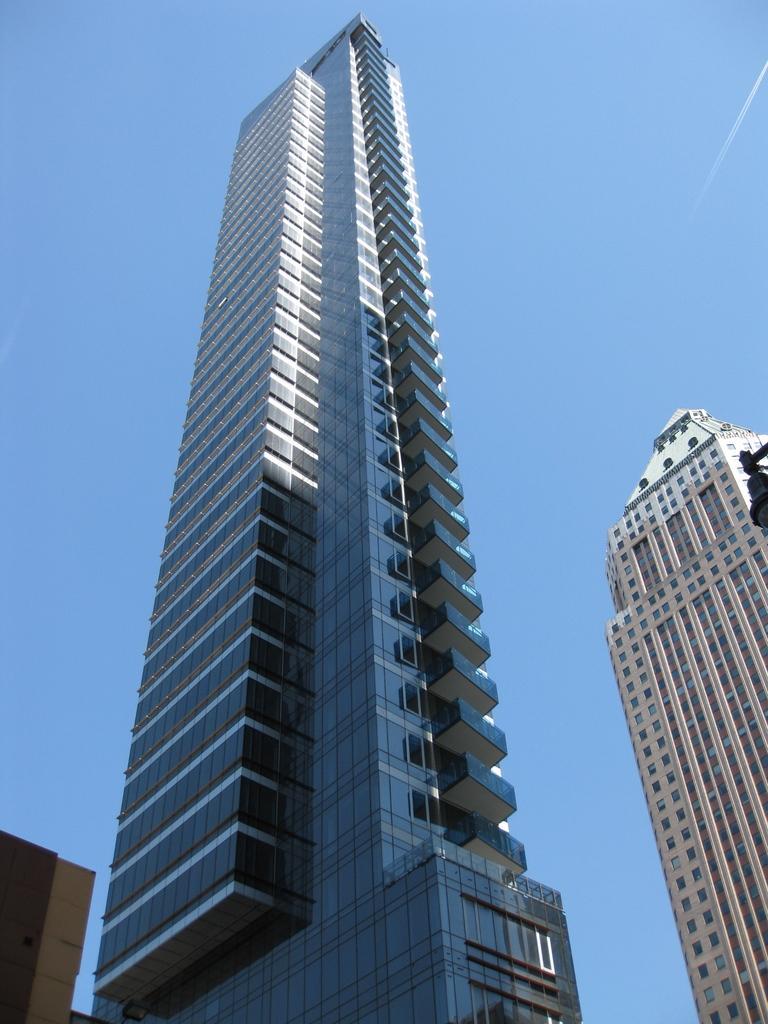In one or two sentences, can you explain what this image depicts? In this image at front there are buildings. At the background there is sky. 